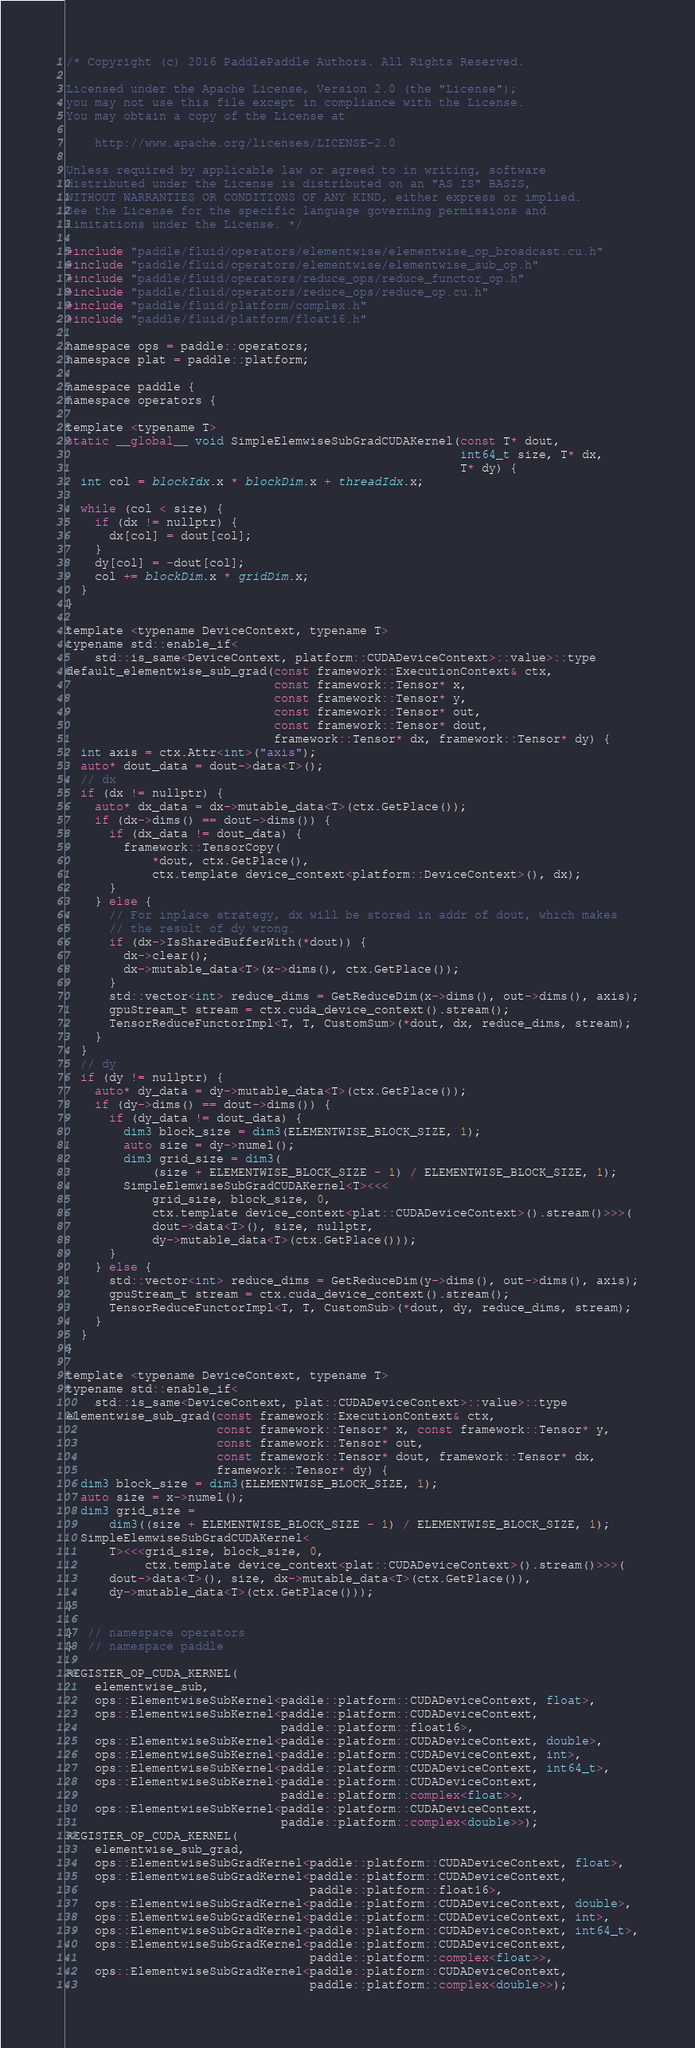Convert code to text. <code><loc_0><loc_0><loc_500><loc_500><_Cuda_>/* Copyright (c) 2016 PaddlePaddle Authors. All Rights Reserved.

Licensed under the Apache License, Version 2.0 (the "License");
you may not use this file except in compliance with the License.
You may obtain a copy of the License at

    http://www.apache.org/licenses/LICENSE-2.0

Unless required by applicable law or agreed to in writing, software
distributed under the License is distributed on an "AS IS" BASIS,
WITHOUT WARRANTIES OR CONDITIONS OF ANY KIND, either express or implied.
See the License for the specific language governing permissions and
limitations under the License. */

#include "paddle/fluid/operators/elementwise/elementwise_op_broadcast.cu.h"
#include "paddle/fluid/operators/elementwise/elementwise_sub_op.h"
#include "paddle/fluid/operators/reduce_ops/reduce_functor_op.h"
#include "paddle/fluid/operators/reduce_ops/reduce_op.cu.h"
#include "paddle/fluid/platform/complex.h"
#include "paddle/fluid/platform/float16.h"

namespace ops = paddle::operators;
namespace plat = paddle::platform;

namespace paddle {
namespace operators {

template <typename T>
static __global__ void SimpleElemwiseSubGradCUDAKernel(const T* dout,
                                                       int64_t size, T* dx,
                                                       T* dy) {
  int col = blockIdx.x * blockDim.x + threadIdx.x;

  while (col < size) {
    if (dx != nullptr) {
      dx[col] = dout[col];
    }
    dy[col] = -dout[col];
    col += blockDim.x * gridDim.x;
  }
}

template <typename DeviceContext, typename T>
typename std::enable_if<
    std::is_same<DeviceContext, platform::CUDADeviceContext>::value>::type
default_elementwise_sub_grad(const framework::ExecutionContext& ctx,
                             const framework::Tensor* x,
                             const framework::Tensor* y,
                             const framework::Tensor* out,
                             const framework::Tensor* dout,
                             framework::Tensor* dx, framework::Tensor* dy) {
  int axis = ctx.Attr<int>("axis");
  auto* dout_data = dout->data<T>();
  // dx
  if (dx != nullptr) {
    auto* dx_data = dx->mutable_data<T>(ctx.GetPlace());
    if (dx->dims() == dout->dims()) {
      if (dx_data != dout_data) {
        framework::TensorCopy(
            *dout, ctx.GetPlace(),
            ctx.template device_context<platform::DeviceContext>(), dx);
      }
    } else {
      // For inplace strategy, dx will be stored in addr of dout, which makes
      // the result of dy wrong.
      if (dx->IsSharedBufferWith(*dout)) {
        dx->clear();
        dx->mutable_data<T>(x->dims(), ctx.GetPlace());
      }
      std::vector<int> reduce_dims = GetReduceDim(x->dims(), out->dims(), axis);
      gpuStream_t stream = ctx.cuda_device_context().stream();
      TensorReduceFunctorImpl<T, T, CustomSum>(*dout, dx, reduce_dims, stream);
    }
  }
  // dy
  if (dy != nullptr) {
    auto* dy_data = dy->mutable_data<T>(ctx.GetPlace());
    if (dy->dims() == dout->dims()) {
      if (dy_data != dout_data) {
        dim3 block_size = dim3(ELEMENTWISE_BLOCK_SIZE, 1);
        auto size = dy->numel();
        dim3 grid_size = dim3(
            (size + ELEMENTWISE_BLOCK_SIZE - 1) / ELEMENTWISE_BLOCK_SIZE, 1);
        SimpleElemwiseSubGradCUDAKernel<T><<<
            grid_size, block_size, 0,
            ctx.template device_context<plat::CUDADeviceContext>().stream()>>>(
            dout->data<T>(), size, nullptr,
            dy->mutable_data<T>(ctx.GetPlace()));
      }
    } else {
      std::vector<int> reduce_dims = GetReduceDim(y->dims(), out->dims(), axis);
      gpuStream_t stream = ctx.cuda_device_context().stream();
      TensorReduceFunctorImpl<T, T, CustomSub>(*dout, dy, reduce_dims, stream);
    }
  }
}

template <typename DeviceContext, typename T>
typename std::enable_if<
    std::is_same<DeviceContext, plat::CUDADeviceContext>::value>::type
elementwise_sub_grad(const framework::ExecutionContext& ctx,
                     const framework::Tensor* x, const framework::Tensor* y,
                     const framework::Tensor* out,
                     const framework::Tensor* dout, framework::Tensor* dx,
                     framework::Tensor* dy) {
  dim3 block_size = dim3(ELEMENTWISE_BLOCK_SIZE, 1);
  auto size = x->numel();
  dim3 grid_size =
      dim3((size + ELEMENTWISE_BLOCK_SIZE - 1) / ELEMENTWISE_BLOCK_SIZE, 1);
  SimpleElemwiseSubGradCUDAKernel<
      T><<<grid_size, block_size, 0,
           ctx.template device_context<plat::CUDADeviceContext>().stream()>>>(
      dout->data<T>(), size, dx->mutable_data<T>(ctx.GetPlace()),
      dy->mutable_data<T>(ctx.GetPlace()));
}

}  // namespace operators
}  // namespace paddle

REGISTER_OP_CUDA_KERNEL(
    elementwise_sub,
    ops::ElementwiseSubKernel<paddle::platform::CUDADeviceContext, float>,
    ops::ElementwiseSubKernel<paddle::platform::CUDADeviceContext,
                              paddle::platform::float16>,
    ops::ElementwiseSubKernel<paddle::platform::CUDADeviceContext, double>,
    ops::ElementwiseSubKernel<paddle::platform::CUDADeviceContext, int>,
    ops::ElementwiseSubKernel<paddle::platform::CUDADeviceContext, int64_t>,
    ops::ElementwiseSubKernel<paddle::platform::CUDADeviceContext,
                              paddle::platform::complex<float>>,
    ops::ElementwiseSubKernel<paddle::platform::CUDADeviceContext,
                              paddle::platform::complex<double>>);
REGISTER_OP_CUDA_KERNEL(
    elementwise_sub_grad,
    ops::ElementwiseSubGradKernel<paddle::platform::CUDADeviceContext, float>,
    ops::ElementwiseSubGradKernel<paddle::platform::CUDADeviceContext,
                                  paddle::platform::float16>,
    ops::ElementwiseSubGradKernel<paddle::platform::CUDADeviceContext, double>,
    ops::ElementwiseSubGradKernel<paddle::platform::CUDADeviceContext, int>,
    ops::ElementwiseSubGradKernel<paddle::platform::CUDADeviceContext, int64_t>,
    ops::ElementwiseSubGradKernel<paddle::platform::CUDADeviceContext,
                                  paddle::platform::complex<float>>,
    ops::ElementwiseSubGradKernel<paddle::platform::CUDADeviceContext,
                                  paddle::platform::complex<double>>);</code> 